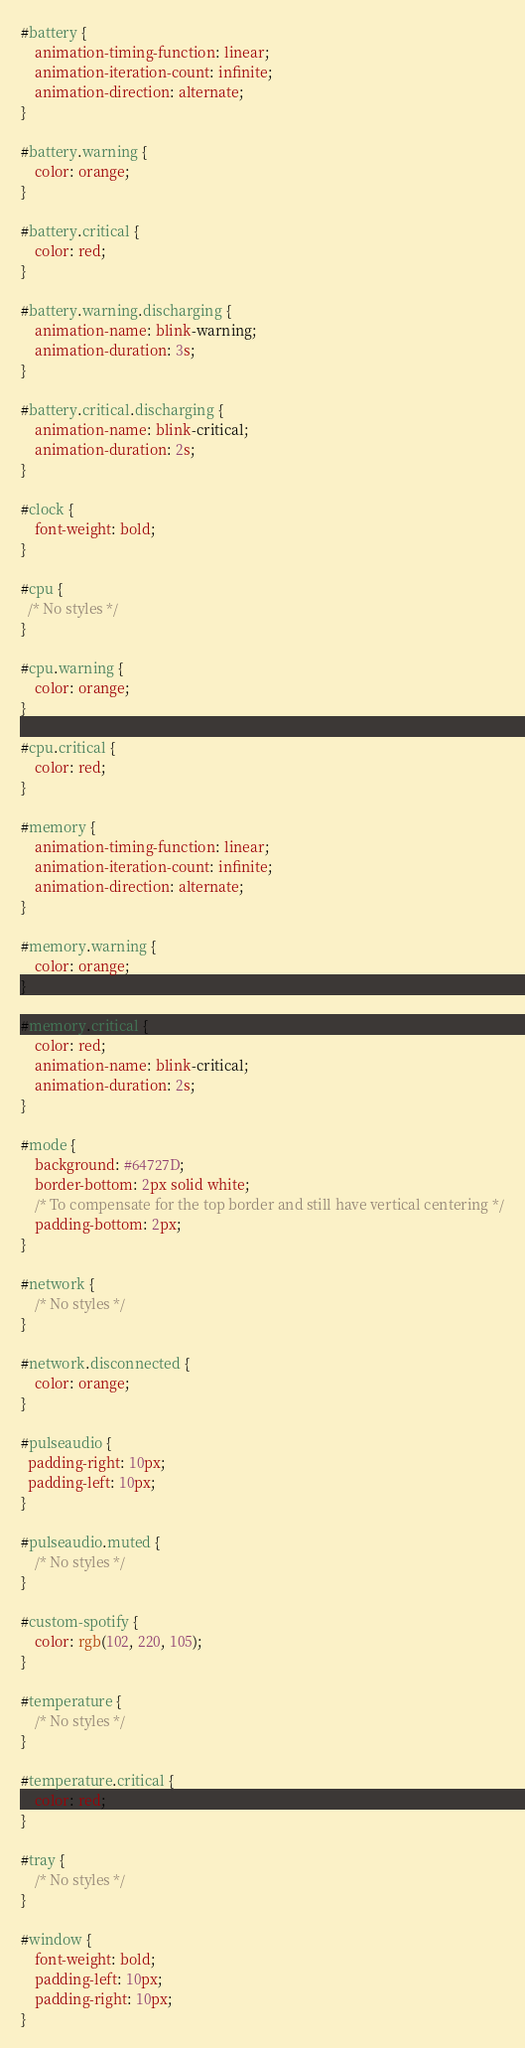<code> <loc_0><loc_0><loc_500><loc_500><_CSS_>#battery {
    animation-timing-function: linear;
    animation-iteration-count: infinite;
    animation-direction: alternate;
}

#battery.warning {
    color: orange;
}

#battery.critical {
    color: red;
}

#battery.warning.discharging {
    animation-name: blink-warning;
    animation-duration: 3s;
}

#battery.critical.discharging {
    animation-name: blink-critical;
    animation-duration: 2s;
}

#clock {
    font-weight: bold;
}

#cpu {
  /* No styles */
}

#cpu.warning {
    color: orange;
}

#cpu.critical {
    color: red;
}

#memory {
    animation-timing-function: linear;
    animation-iteration-count: infinite;
    animation-direction: alternate;
}

#memory.warning {
    color: orange;
}

#memory.critical {
    color: red;
    animation-name: blink-critical;
    animation-duration: 2s;
}

#mode {
    background: #64727D;
    border-bottom: 2px solid white;
    /* To compensate for the top border and still have vertical centering */
    padding-bottom: 2px;
}

#network {
    /* No styles */
}

#network.disconnected {
    color: orange;
}

#pulseaudio {
  padding-right: 10px;
  padding-left: 10px;
}

#pulseaudio.muted {
    /* No styles */
}

#custom-spotify {
    color: rgb(102, 220, 105);
}

#temperature {
    /* No styles */
}

#temperature.critical {
    color: red;
}

#tray {
    /* No styles */
}

#window {
    font-weight: bold;
    padding-left: 10px;
    padding-right: 10px;
}

</code> 